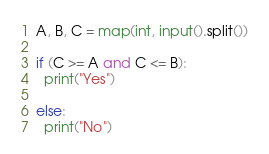<code> <loc_0><loc_0><loc_500><loc_500><_Python_>A, B, C = map(int, input().split())
 
if (C >= A and C <= B):
  print("Yes")
  
else:
  print("No")
</code> 